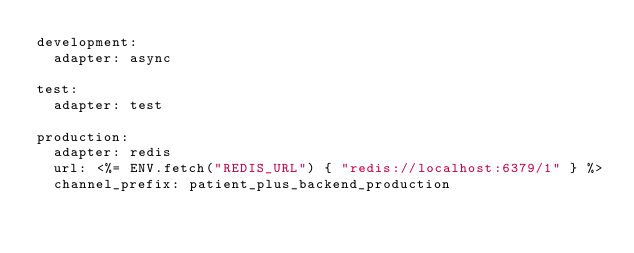Convert code to text. <code><loc_0><loc_0><loc_500><loc_500><_YAML_>development:
  adapter: async

test:
  adapter: test

production:
  adapter: redis
  url: <%= ENV.fetch("REDIS_URL") { "redis://localhost:6379/1" } %>
  channel_prefix: patient_plus_backend_production
</code> 